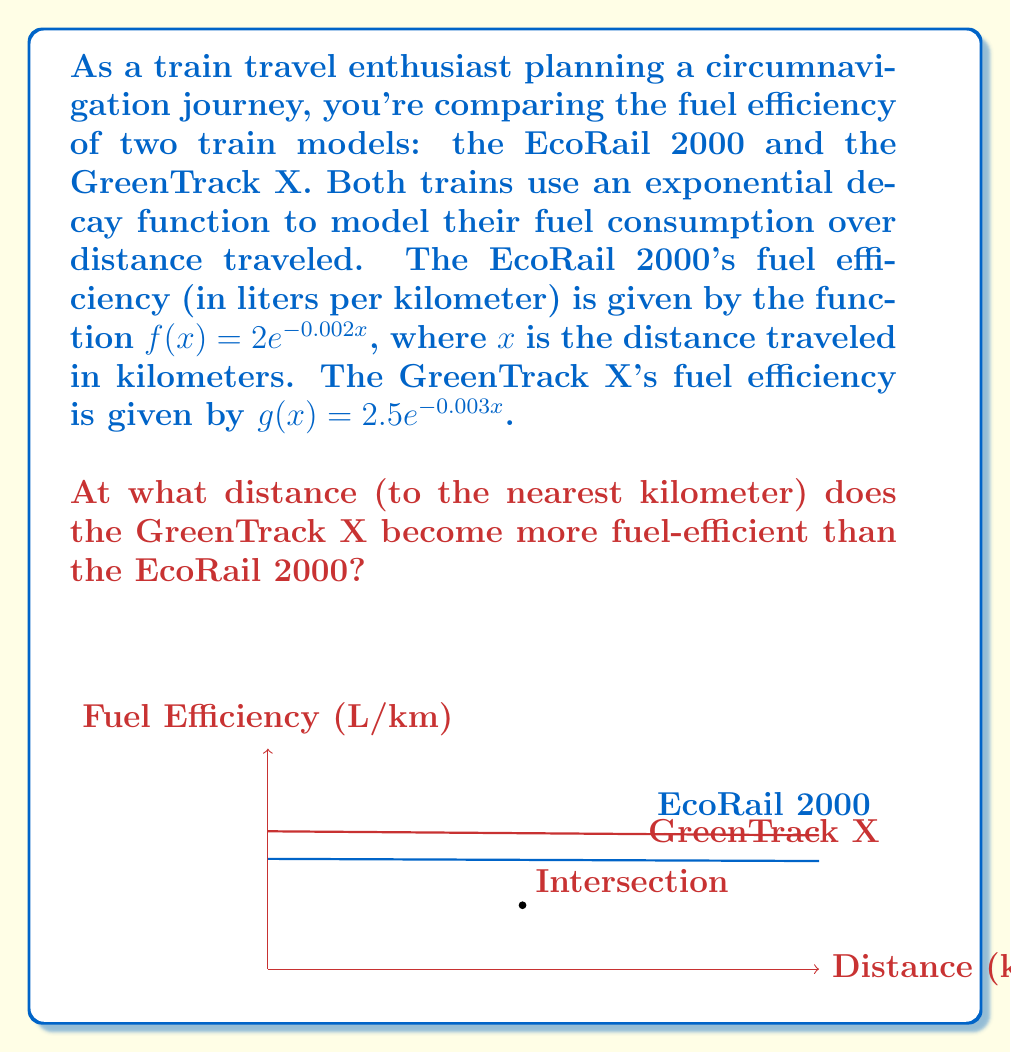What is the answer to this math problem? To solve this problem, we need to find the point where the two functions intersect. At this point, the fuel efficiency of both trains will be equal, and beyond this point, the GreenTrack X will be more fuel-efficient.

1) Set the two functions equal to each other:
   $$2e^{-0.002x} = 2.5e^{-0.003x}$$

2) Take the natural logarithm of both sides:
   $$\ln(2e^{-0.002x}) = \ln(2.5e^{-0.003x})$$

3) Use the properties of logarithms:
   $$\ln(2) - 0.002x = \ln(2.5) - 0.003x$$

4) Solve for x:
   $$-0.002x + 0.003x = \ln(2.5) - \ln(2)$$
   $$0.001x = \ln(1.25)$$
   $$x = \frac{\ln(1.25)}{0.001}$$

5) Calculate the result:
   $$x \approx 461.65$$

6) Round to the nearest kilometer:
   $$x \approx 462 \text{ km}$$

Therefore, at approximately 462 km, the GreenTrack X becomes more fuel-efficient than the EcoRail 2000.
Answer: 462 km 